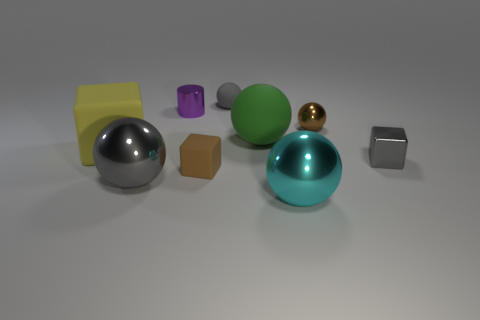Subtract all brown blocks. How many blocks are left? 2 Subtract 1 cylinders. How many cylinders are left? 0 Subtract all cylinders. How many objects are left? 8 Subtract all brown balls. How many balls are left? 4 Add 9 small red matte spheres. How many small red matte spheres exist? 9 Add 1 big red metal cylinders. How many objects exist? 10 Subtract 1 brown cubes. How many objects are left? 8 Subtract all green cubes. Subtract all brown spheres. How many cubes are left? 3 Subtract all purple cylinders. How many gray cubes are left? 1 Subtract all big yellow things. Subtract all tiny cubes. How many objects are left? 6 